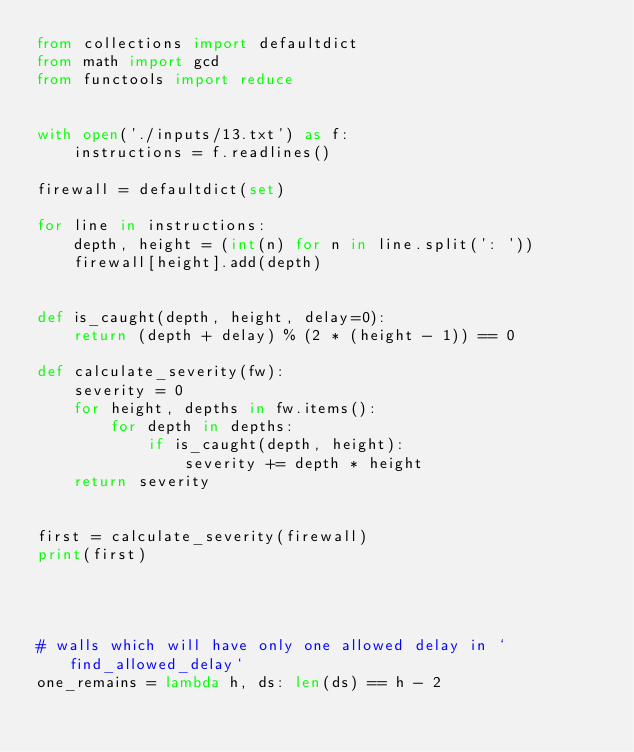Convert code to text. <code><loc_0><loc_0><loc_500><loc_500><_Python_>from collections import defaultdict
from math import gcd
from functools import reduce


with open('./inputs/13.txt') as f:
    instructions = f.readlines()

firewall = defaultdict(set)

for line in instructions:
    depth, height = (int(n) for n in line.split(': '))
    firewall[height].add(depth)


def is_caught(depth, height, delay=0):
    return (depth + delay) % (2 * (height - 1)) == 0

def calculate_severity(fw):
    severity = 0
    for height, depths in fw.items():
        for depth in depths:
            if is_caught(depth, height):
                severity += depth * height
    return severity


first = calculate_severity(firewall)
print(first)




# walls which will have only one allowed delay in `find_allowed_delay`
one_remains = lambda h, ds: len(ds) == h - 2
</code> 